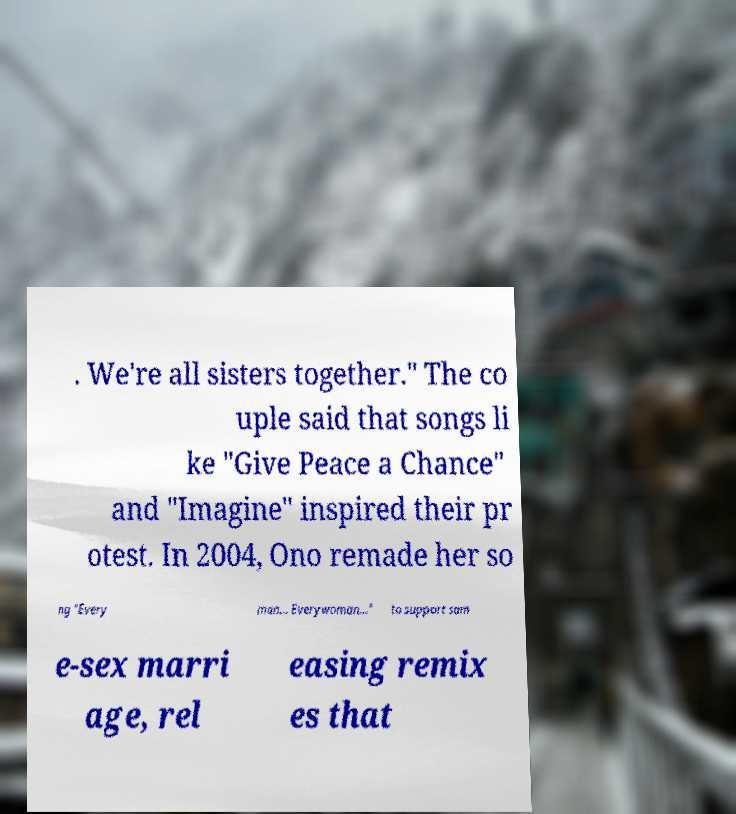Can you accurately transcribe the text from the provided image for me? . We're all sisters together." The co uple said that songs li ke "Give Peace a Chance" and "Imagine" inspired their pr otest. In 2004, Ono remade her so ng "Every man... Everywoman..." to support sam e-sex marri age, rel easing remix es that 